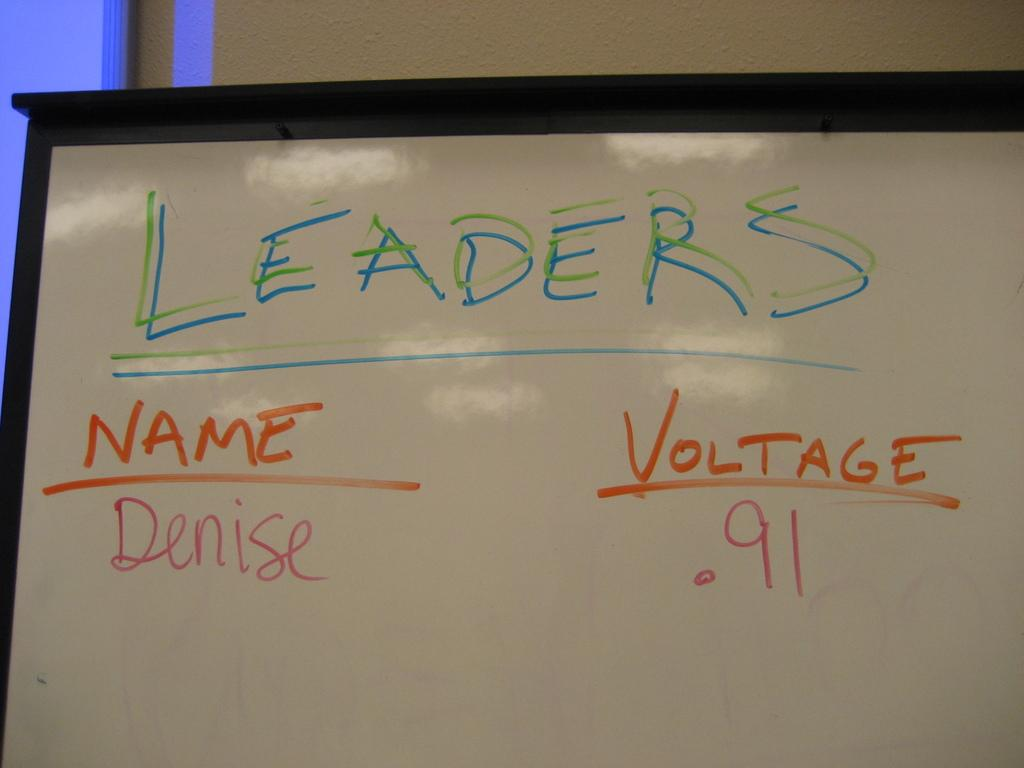Provide a one-sentence caption for the provided image. A whiteboard with writing on it labelled Leaders. 